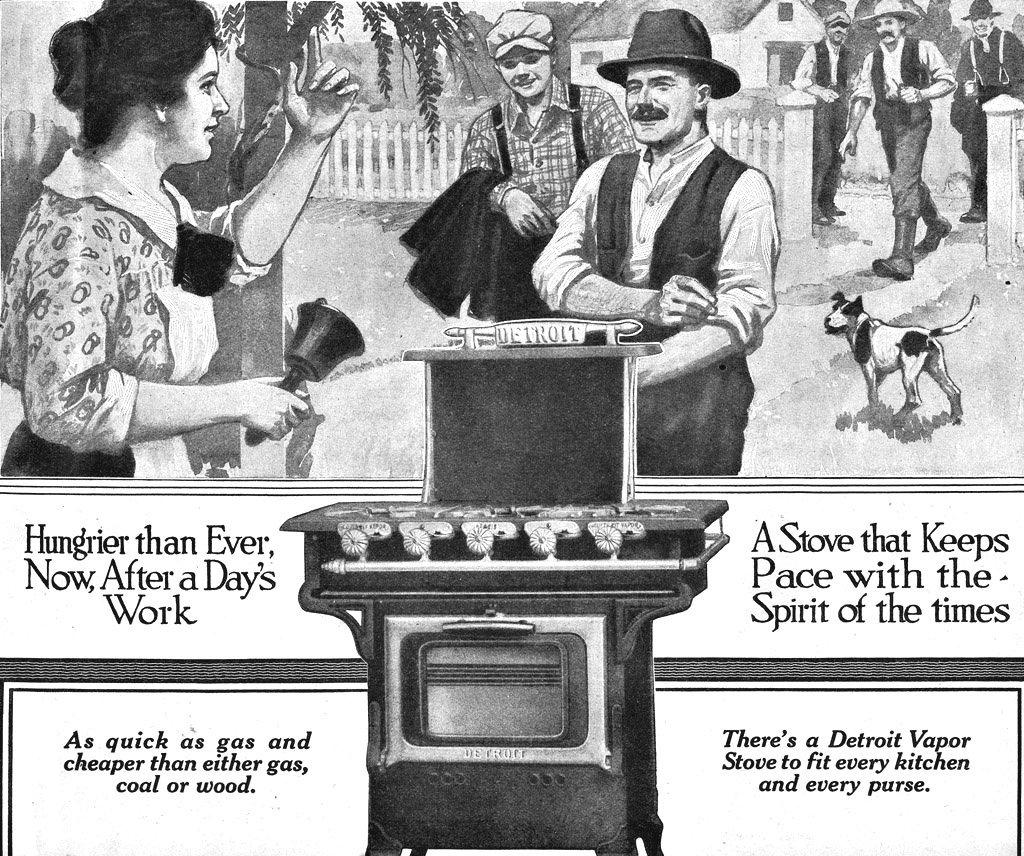<image>
Render a clear and concise summary of the photo. An advertisement for a stove that says Hungrier than ever, now, after a days work. 